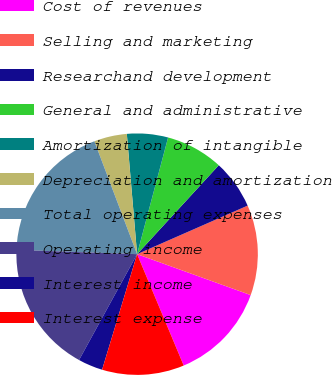Convert chart. <chart><loc_0><loc_0><loc_500><loc_500><pie_chart><fcel>Cost of revenues<fcel>Selling and marketing<fcel>Researchand development<fcel>General and administrative<fcel>Amortization of intangible<fcel>Depreciation and amortization<fcel>Total operating expenses<fcel>Operating income<fcel>Interest income<fcel>Interest expense<nl><fcel>13.19%<fcel>12.09%<fcel>6.59%<fcel>7.69%<fcel>5.49%<fcel>4.4%<fcel>18.68%<fcel>17.58%<fcel>3.3%<fcel>10.99%<nl></chart> 